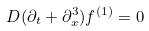Convert formula to latex. <formula><loc_0><loc_0><loc_500><loc_500>D ( \partial _ { t } + \partial _ { x } ^ { 3 } ) f ^ { ( 1 ) } = 0</formula> 